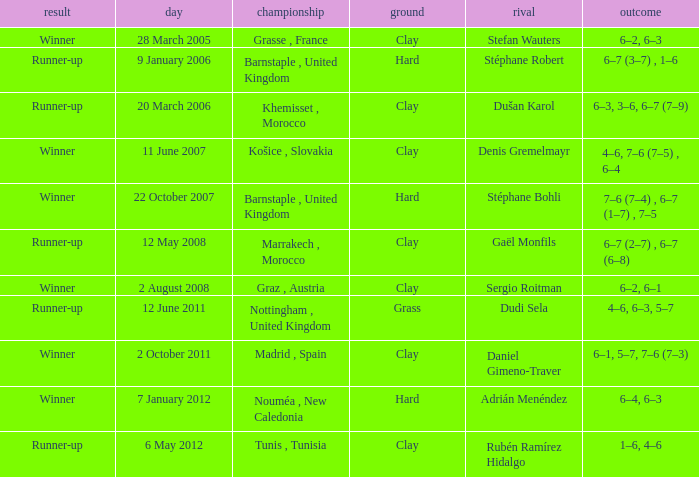What is the score on 2 October 2011? 6–1, 5–7, 7–6 (7–3). 